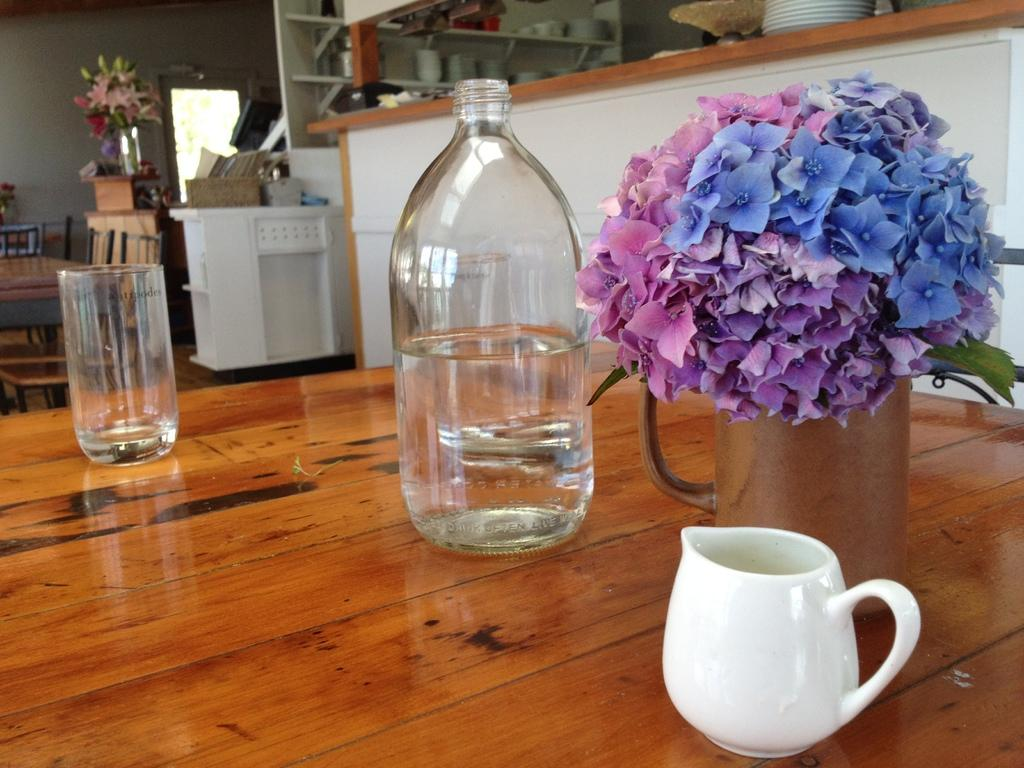What type of container is visible in the image? There is a water bottle in the image. What else can be seen in the image besides the water bottle? There are flowers in a jug, a cup, and a glass in the image. Where are all the objects located? All objects are on a table. What type of cheese is present in the image? There is no cheese present in the image. How does the spark from the flowers in the jug illuminate the room in the image? There is no spark or illumination mentioned in the image; the flowers are simply in a jug. 